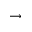<formula> <loc_0><loc_0><loc_500><loc_500>\rightarrow</formula> 